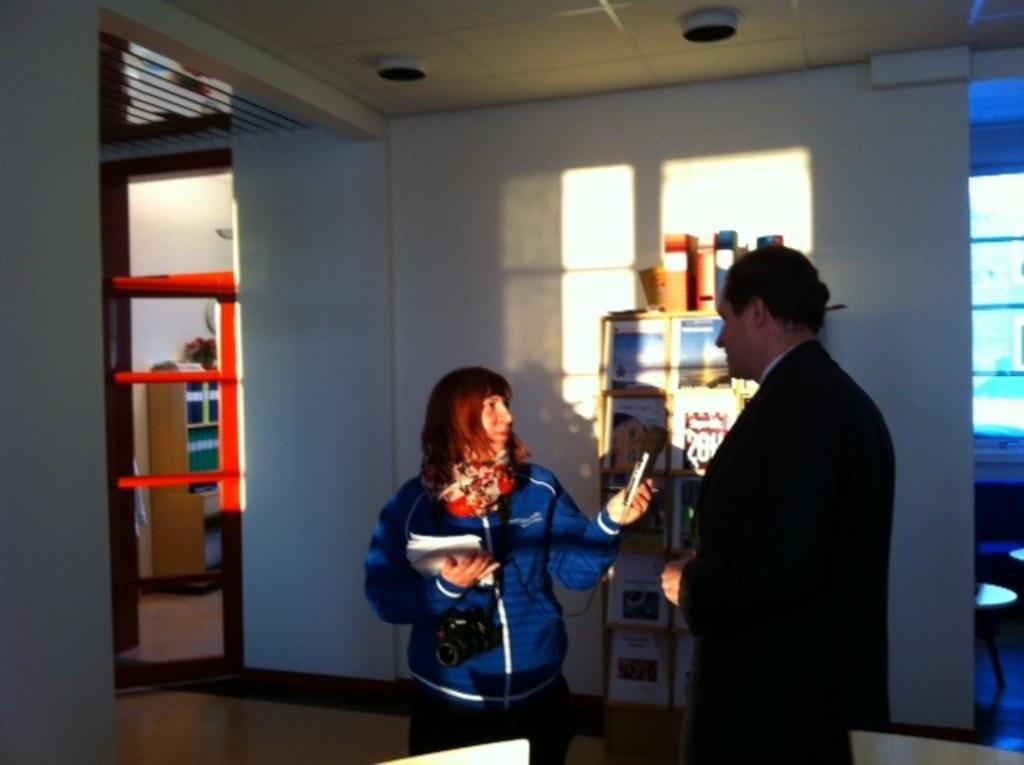In one or two sentences, can you explain what this image depicts? There are two persons on the floor. This person is holding papers, camera, and a device. There are frames, door, and objects. Here we can see chairs, glasses, and ceiling. 